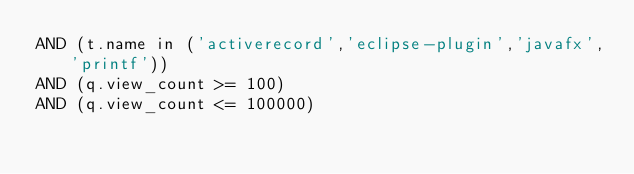Convert code to text. <code><loc_0><loc_0><loc_500><loc_500><_SQL_>AND (t.name in ('activerecord','eclipse-plugin','javafx','printf'))
AND (q.view_count >= 100)
AND (q.view_count <= 100000)
</code> 